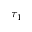Convert formula to latex. <formula><loc_0><loc_0><loc_500><loc_500>\tau _ { 1 }</formula> 